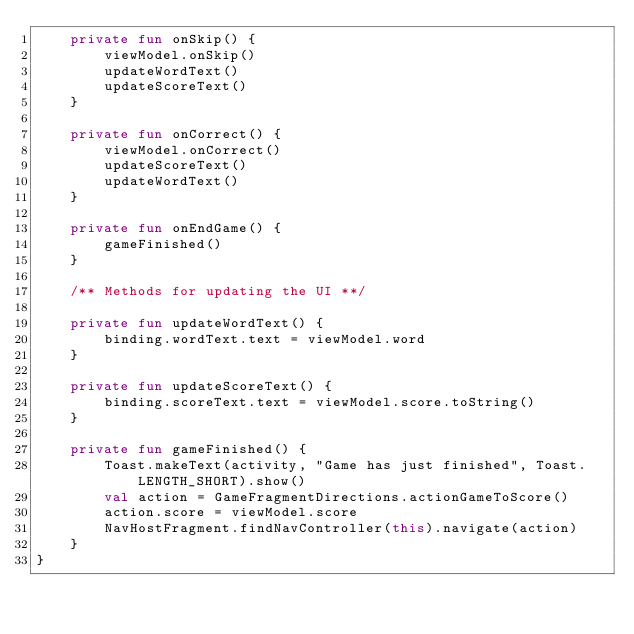Convert code to text. <code><loc_0><loc_0><loc_500><loc_500><_Kotlin_>    private fun onSkip() {
        viewModel.onSkip()
        updateWordText()
        updateScoreText()
    }

    private fun onCorrect() {
        viewModel.onCorrect()
        updateScoreText()
        updateWordText()
    }

    private fun onEndGame() {
        gameFinished()
    }

    /** Methods for updating the UI **/

    private fun updateWordText() {
        binding.wordText.text = viewModel.word
    }

    private fun updateScoreText() {
        binding.scoreText.text = viewModel.score.toString()
    }

    private fun gameFinished() {
        Toast.makeText(activity, "Game has just finished", Toast.LENGTH_SHORT).show()
        val action = GameFragmentDirections.actionGameToScore()
        action.score = viewModel.score
        NavHostFragment.findNavController(this).navigate(action)
    }
}
</code> 